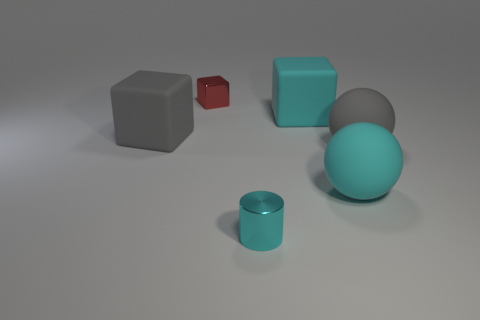Subtract all red blocks. Subtract all brown spheres. How many blocks are left? 2 Add 1 large brown metallic cubes. How many objects exist? 7 Subtract all spheres. How many objects are left? 4 Subtract 0 red cylinders. How many objects are left? 6 Subtract all blue metal spheres. Subtract all big cyan things. How many objects are left? 4 Add 5 small red metallic objects. How many small red metallic objects are left? 6 Add 3 cylinders. How many cylinders exist? 4 